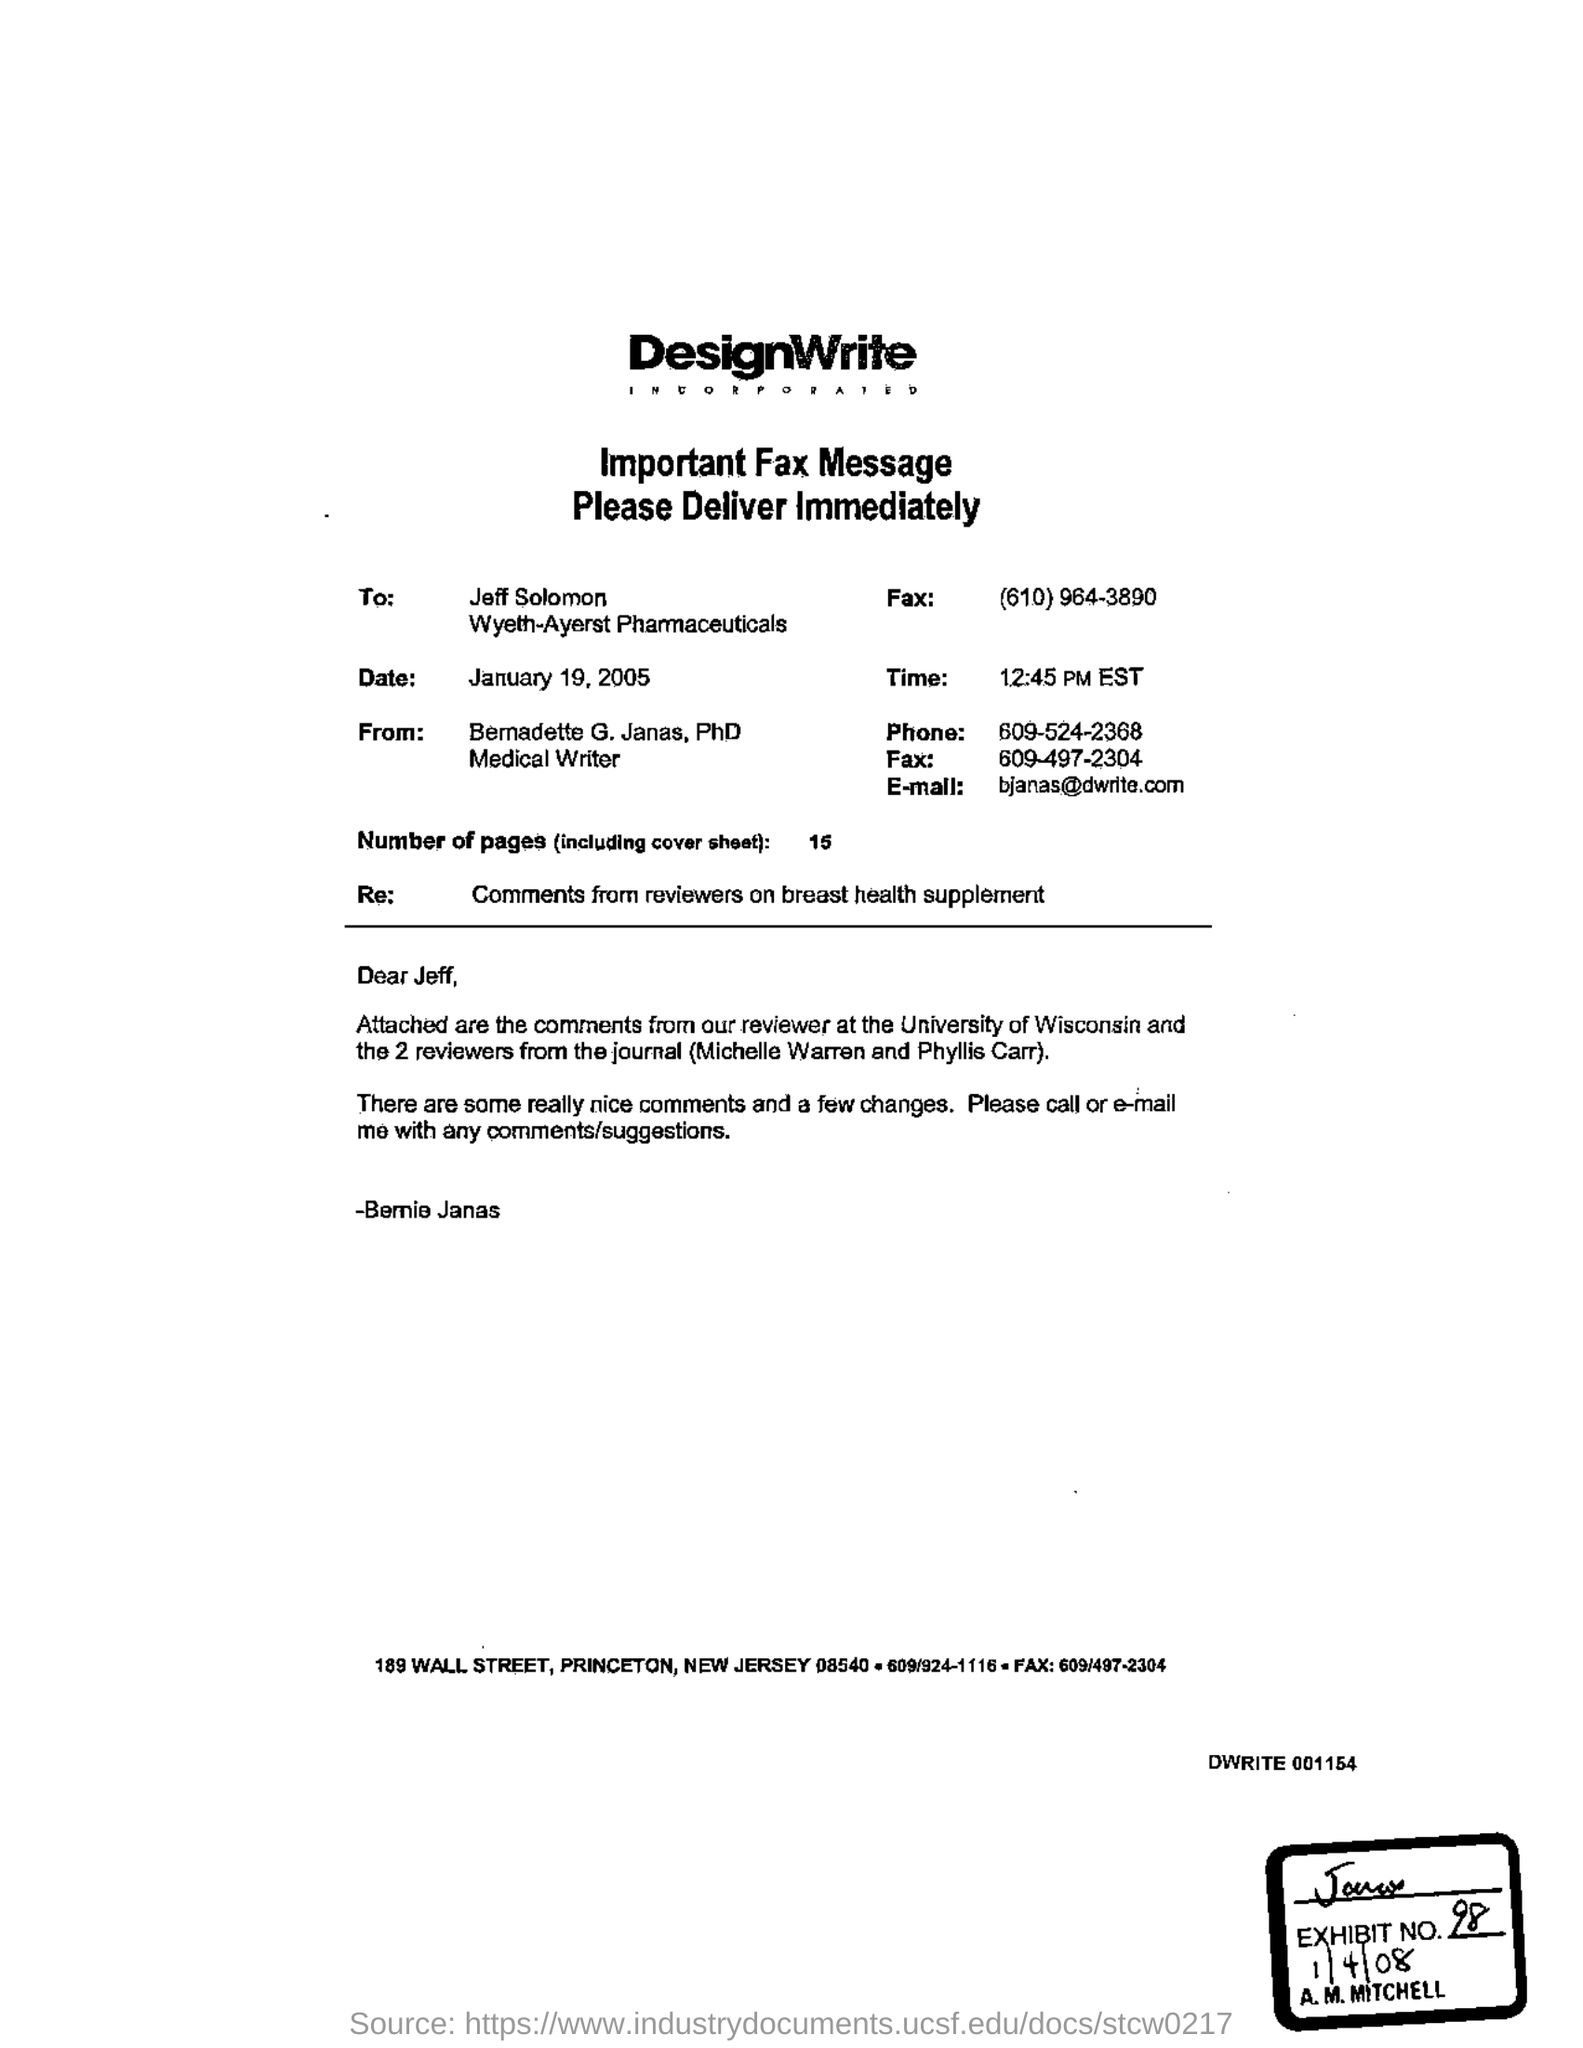Give some essential details in this illustration. The e-mail address is [bjanas@dwrite.com](mailto:bjanas@dwrite.com). The time is 12:45 PM EST. The salutation of the letter is "Dear Jeff. The number of pages is 15.. 